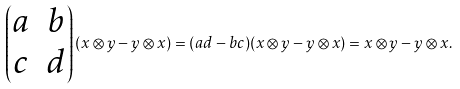Convert formula to latex. <formula><loc_0><loc_0><loc_500><loc_500>\begin{pmatrix} a & b \\ c & d \end{pmatrix} ( x \otimes y - y \otimes x ) = ( a d - b c ) ( x \otimes y - y \otimes x ) = x \otimes y - y \otimes x .</formula> 